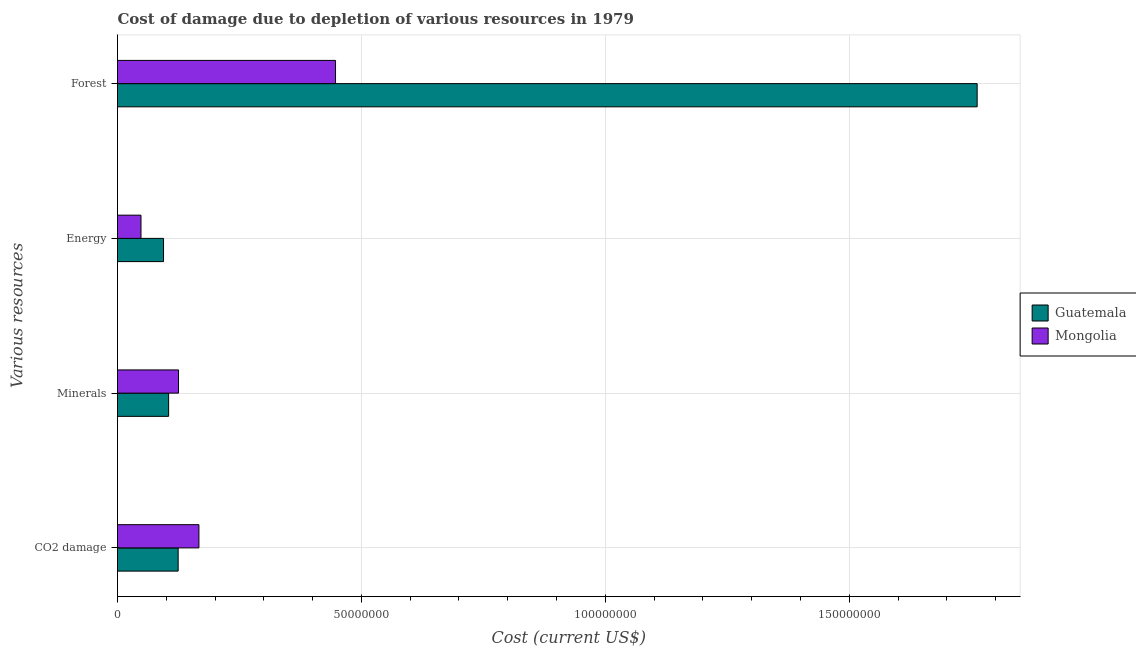Are the number of bars per tick equal to the number of legend labels?
Your answer should be very brief. Yes. Are the number of bars on each tick of the Y-axis equal?
Keep it short and to the point. Yes. How many bars are there on the 1st tick from the top?
Make the answer very short. 2. What is the label of the 2nd group of bars from the top?
Your response must be concise. Energy. What is the cost of damage due to depletion of coal in Guatemala?
Ensure brevity in your answer.  1.24e+07. Across all countries, what is the maximum cost of damage due to depletion of forests?
Your answer should be very brief. 1.76e+08. Across all countries, what is the minimum cost of damage due to depletion of coal?
Ensure brevity in your answer.  1.24e+07. In which country was the cost of damage due to depletion of energy maximum?
Offer a very short reply. Guatemala. In which country was the cost of damage due to depletion of energy minimum?
Keep it short and to the point. Mongolia. What is the total cost of damage due to depletion of forests in the graph?
Make the answer very short. 2.21e+08. What is the difference between the cost of damage due to depletion of forests in Mongolia and that in Guatemala?
Offer a very short reply. -1.32e+08. What is the difference between the cost of damage due to depletion of minerals in Guatemala and the cost of damage due to depletion of forests in Mongolia?
Keep it short and to the point. -3.42e+07. What is the average cost of damage due to depletion of minerals per country?
Your answer should be very brief. 1.15e+07. What is the difference between the cost of damage due to depletion of coal and cost of damage due to depletion of forests in Guatemala?
Your answer should be compact. -1.64e+08. In how many countries, is the cost of damage due to depletion of forests greater than 30000000 US$?
Make the answer very short. 2. What is the ratio of the cost of damage due to depletion of coal in Mongolia to that in Guatemala?
Ensure brevity in your answer.  1.34. What is the difference between the highest and the second highest cost of damage due to depletion of forests?
Your answer should be compact. 1.32e+08. What is the difference between the highest and the lowest cost of damage due to depletion of forests?
Keep it short and to the point. 1.32e+08. In how many countries, is the cost of damage due to depletion of energy greater than the average cost of damage due to depletion of energy taken over all countries?
Your response must be concise. 1. Is the sum of the cost of damage due to depletion of energy in Guatemala and Mongolia greater than the maximum cost of damage due to depletion of minerals across all countries?
Offer a terse response. Yes. Is it the case that in every country, the sum of the cost of damage due to depletion of coal and cost of damage due to depletion of forests is greater than the sum of cost of damage due to depletion of minerals and cost of damage due to depletion of energy?
Your answer should be very brief. Yes. What does the 2nd bar from the top in CO2 damage represents?
Provide a short and direct response. Guatemala. What does the 1st bar from the bottom in CO2 damage represents?
Your response must be concise. Guatemala. Is it the case that in every country, the sum of the cost of damage due to depletion of coal and cost of damage due to depletion of minerals is greater than the cost of damage due to depletion of energy?
Give a very brief answer. Yes. How many bars are there?
Offer a very short reply. 8. What is the difference between two consecutive major ticks on the X-axis?
Offer a terse response. 5.00e+07. Does the graph contain any zero values?
Your answer should be very brief. No. Does the graph contain grids?
Make the answer very short. Yes. Where does the legend appear in the graph?
Make the answer very short. Center right. How many legend labels are there?
Keep it short and to the point. 2. What is the title of the graph?
Provide a short and direct response. Cost of damage due to depletion of various resources in 1979 . What is the label or title of the X-axis?
Provide a succinct answer. Cost (current US$). What is the label or title of the Y-axis?
Offer a very short reply. Various resources. What is the Cost (current US$) in Guatemala in CO2 damage?
Offer a terse response. 1.24e+07. What is the Cost (current US$) of Mongolia in CO2 damage?
Give a very brief answer. 1.67e+07. What is the Cost (current US$) in Guatemala in Minerals?
Offer a terse response. 1.05e+07. What is the Cost (current US$) of Mongolia in Minerals?
Your response must be concise. 1.25e+07. What is the Cost (current US$) in Guatemala in Energy?
Ensure brevity in your answer.  9.43e+06. What is the Cost (current US$) in Mongolia in Energy?
Your answer should be very brief. 4.81e+06. What is the Cost (current US$) in Guatemala in Forest?
Your answer should be very brief. 1.76e+08. What is the Cost (current US$) of Mongolia in Forest?
Give a very brief answer. 4.47e+07. Across all Various resources, what is the maximum Cost (current US$) in Guatemala?
Ensure brevity in your answer.  1.76e+08. Across all Various resources, what is the maximum Cost (current US$) in Mongolia?
Your response must be concise. 4.47e+07. Across all Various resources, what is the minimum Cost (current US$) of Guatemala?
Provide a short and direct response. 9.43e+06. Across all Various resources, what is the minimum Cost (current US$) in Mongolia?
Offer a very short reply. 4.81e+06. What is the total Cost (current US$) in Guatemala in the graph?
Keep it short and to the point. 2.09e+08. What is the total Cost (current US$) of Mongolia in the graph?
Your answer should be compact. 7.87e+07. What is the difference between the Cost (current US$) in Guatemala in CO2 damage and that in Minerals?
Ensure brevity in your answer.  1.96e+06. What is the difference between the Cost (current US$) in Mongolia in CO2 damage and that in Minerals?
Give a very brief answer. 4.18e+06. What is the difference between the Cost (current US$) of Guatemala in CO2 damage and that in Energy?
Offer a terse response. 3.00e+06. What is the difference between the Cost (current US$) in Mongolia in CO2 damage and that in Energy?
Keep it short and to the point. 1.19e+07. What is the difference between the Cost (current US$) of Guatemala in CO2 damage and that in Forest?
Keep it short and to the point. -1.64e+08. What is the difference between the Cost (current US$) of Mongolia in CO2 damage and that in Forest?
Provide a succinct answer. -2.80e+07. What is the difference between the Cost (current US$) of Guatemala in Minerals and that in Energy?
Provide a short and direct response. 1.04e+06. What is the difference between the Cost (current US$) in Mongolia in Minerals and that in Energy?
Ensure brevity in your answer.  7.69e+06. What is the difference between the Cost (current US$) of Guatemala in Minerals and that in Forest?
Your answer should be very brief. -1.66e+08. What is the difference between the Cost (current US$) in Mongolia in Minerals and that in Forest?
Your answer should be very brief. -3.22e+07. What is the difference between the Cost (current US$) of Guatemala in Energy and that in Forest?
Your response must be concise. -1.67e+08. What is the difference between the Cost (current US$) of Mongolia in Energy and that in Forest?
Your response must be concise. -3.99e+07. What is the difference between the Cost (current US$) of Guatemala in CO2 damage and the Cost (current US$) of Mongolia in Minerals?
Your answer should be compact. -7.18e+04. What is the difference between the Cost (current US$) in Guatemala in CO2 damage and the Cost (current US$) in Mongolia in Energy?
Your answer should be compact. 7.62e+06. What is the difference between the Cost (current US$) in Guatemala in CO2 damage and the Cost (current US$) in Mongolia in Forest?
Provide a short and direct response. -3.23e+07. What is the difference between the Cost (current US$) of Guatemala in Minerals and the Cost (current US$) of Mongolia in Energy?
Keep it short and to the point. 5.67e+06. What is the difference between the Cost (current US$) of Guatemala in Minerals and the Cost (current US$) of Mongolia in Forest?
Provide a succinct answer. -3.42e+07. What is the difference between the Cost (current US$) of Guatemala in Energy and the Cost (current US$) of Mongolia in Forest?
Give a very brief answer. -3.53e+07. What is the average Cost (current US$) of Guatemala per Various resources?
Your answer should be compact. 5.21e+07. What is the average Cost (current US$) of Mongolia per Various resources?
Provide a short and direct response. 1.97e+07. What is the difference between the Cost (current US$) in Guatemala and Cost (current US$) in Mongolia in CO2 damage?
Offer a terse response. -4.25e+06. What is the difference between the Cost (current US$) of Guatemala and Cost (current US$) of Mongolia in Minerals?
Offer a terse response. -2.03e+06. What is the difference between the Cost (current US$) in Guatemala and Cost (current US$) in Mongolia in Energy?
Make the answer very short. 4.62e+06. What is the difference between the Cost (current US$) of Guatemala and Cost (current US$) of Mongolia in Forest?
Offer a terse response. 1.32e+08. What is the ratio of the Cost (current US$) of Guatemala in CO2 damage to that in Minerals?
Make the answer very short. 1.19. What is the ratio of the Cost (current US$) in Mongolia in CO2 damage to that in Minerals?
Your answer should be very brief. 1.33. What is the ratio of the Cost (current US$) of Guatemala in CO2 damage to that in Energy?
Your answer should be very brief. 1.32. What is the ratio of the Cost (current US$) of Mongolia in CO2 damage to that in Energy?
Make the answer very short. 3.47. What is the ratio of the Cost (current US$) of Guatemala in CO2 damage to that in Forest?
Your answer should be very brief. 0.07. What is the ratio of the Cost (current US$) in Mongolia in CO2 damage to that in Forest?
Make the answer very short. 0.37. What is the ratio of the Cost (current US$) in Guatemala in Minerals to that in Energy?
Provide a short and direct response. 1.11. What is the ratio of the Cost (current US$) in Mongolia in Minerals to that in Energy?
Offer a terse response. 2.6. What is the ratio of the Cost (current US$) of Guatemala in Minerals to that in Forest?
Keep it short and to the point. 0.06. What is the ratio of the Cost (current US$) in Mongolia in Minerals to that in Forest?
Ensure brevity in your answer.  0.28. What is the ratio of the Cost (current US$) in Guatemala in Energy to that in Forest?
Give a very brief answer. 0.05. What is the ratio of the Cost (current US$) of Mongolia in Energy to that in Forest?
Provide a succinct answer. 0.11. What is the difference between the highest and the second highest Cost (current US$) of Guatemala?
Provide a succinct answer. 1.64e+08. What is the difference between the highest and the second highest Cost (current US$) of Mongolia?
Your answer should be very brief. 2.80e+07. What is the difference between the highest and the lowest Cost (current US$) in Guatemala?
Offer a terse response. 1.67e+08. What is the difference between the highest and the lowest Cost (current US$) of Mongolia?
Offer a very short reply. 3.99e+07. 